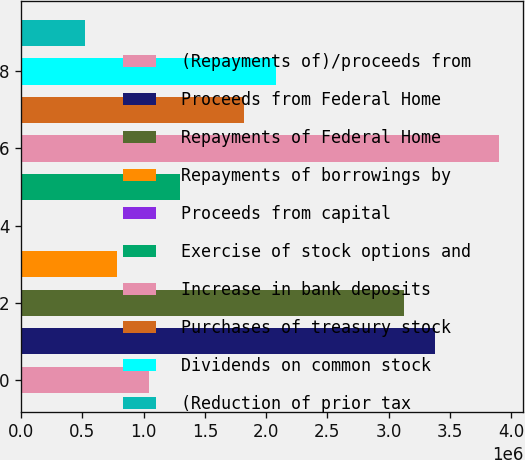<chart> <loc_0><loc_0><loc_500><loc_500><bar_chart><fcel>(Repayments of)/proceeds from<fcel>Proceeds from Federal Home<fcel>Repayments of Federal Home<fcel>Repayments of borrowings by<fcel>Proceeds from capital<fcel>Exercise of stock options and<fcel>Increase in bank deposits<fcel>Purchases of treasury stock<fcel>Dividends on common stock<fcel>(Reduction of prior tax<nl><fcel>1.04047e+06<fcel>3.38127e+06<fcel>3.12119e+06<fcel>780379<fcel>110<fcel>1.30056e+06<fcel>3.90145e+06<fcel>1.82074e+06<fcel>2.08083e+06<fcel>520289<nl></chart> 